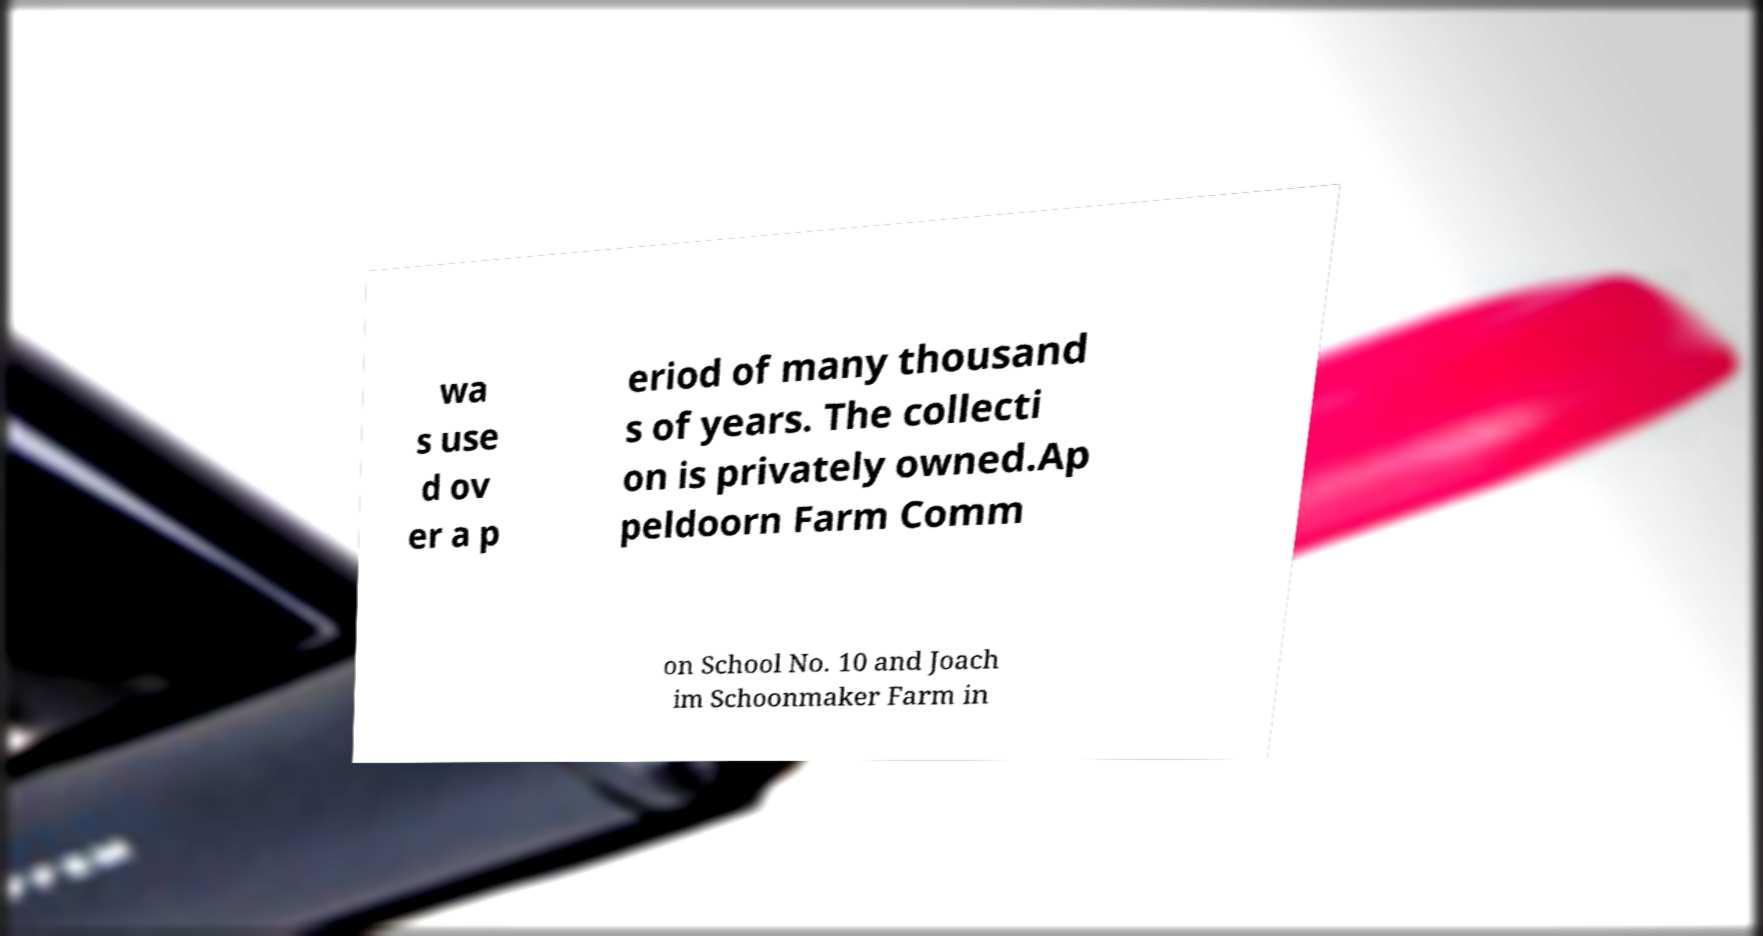Please read and relay the text visible in this image. What does it say? wa s use d ov er a p eriod of many thousand s of years. The collecti on is privately owned.Ap peldoorn Farm Comm on School No. 10 and Joach im Schoonmaker Farm in 